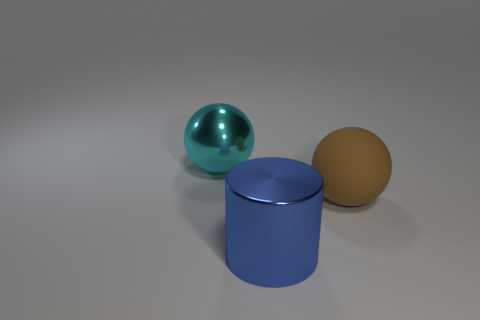Can you describe the texture of the cylinder's surface? The cylinder's surface appears smooth and has a satin-like finish with a slight sheen, suggesting it might be made of a material such as painted metal or plastic. Its texture contrasts with the highly reflective surface of the nearby sphere. 